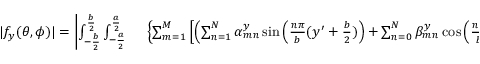<formula> <loc_0><loc_0><loc_500><loc_500>\begin{array} { r l } { | f _ { y } ( \theta , \phi ) | = \left | \int _ { - \frac { b } { 2 } } ^ { \frac { b } { 2 } } { \int _ { - \frac { a } { 2 } } ^ { \frac { a } { 2 } } } & \left \{ \sum _ { m = 1 } ^ { M } \left [ \left ( \sum _ { n = 1 } ^ { N } \alpha _ { m n } ^ { y } \sin \left ( \frac { n \pi } { b } ( y ^ { \prime } + \frac { b } { 2 } ) \right ) + \sum _ { n = 0 } ^ { N } \beta _ { m n } ^ { y } \cos \left ( \frac { n \pi } { b } ( y ^ { \prime } + \frac { b } { 2 } ) \right ) \right ) \sin \left ( \frac { m \pi } { a } ( x ^ { \prime } + \frac { a } { 2 } ) \right ) \right ] \right \} } \end{array}</formula> 